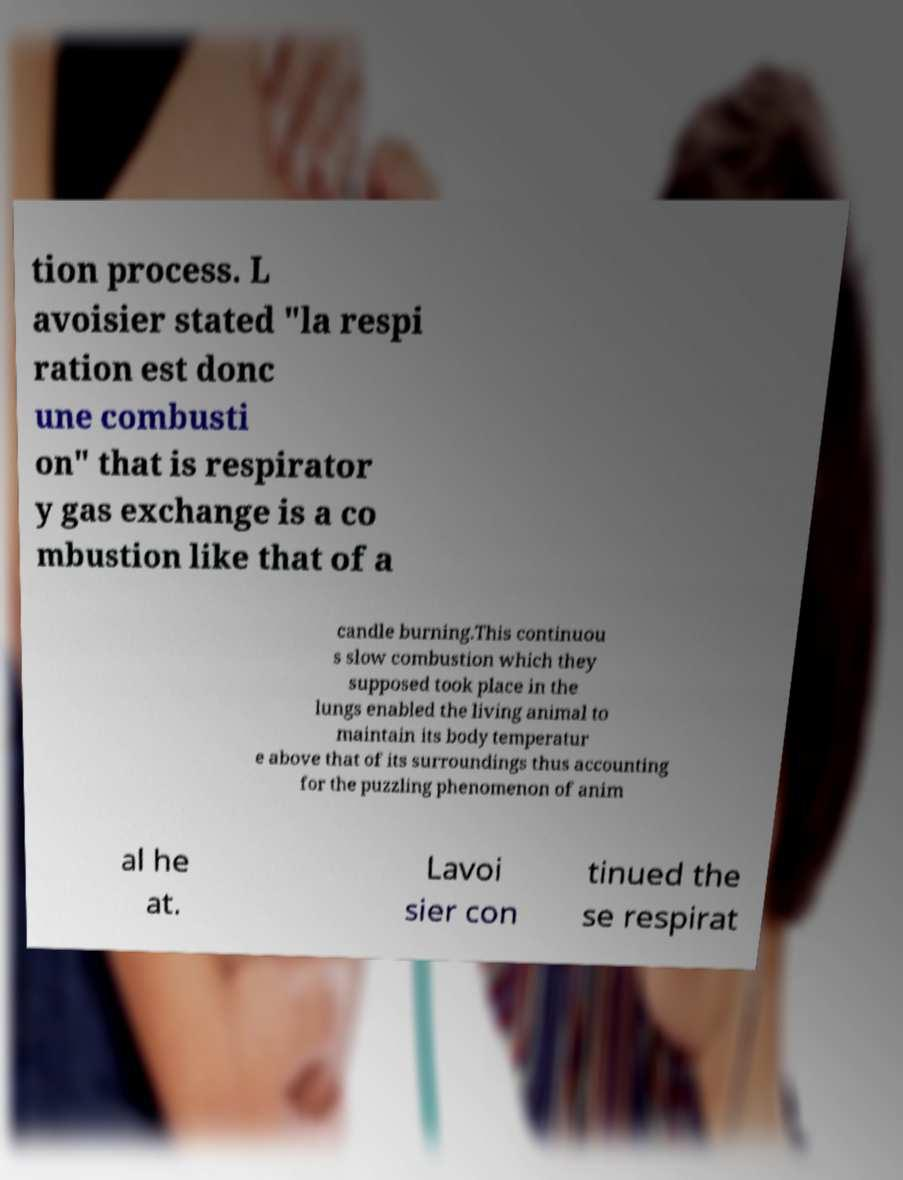Can you read and provide the text displayed in the image?This photo seems to have some interesting text. Can you extract and type it out for me? tion process. L avoisier stated "la respi ration est donc une combusti on" that is respirator y gas exchange is a co mbustion like that of a candle burning.This continuou s slow combustion which they supposed took place in the lungs enabled the living animal to maintain its body temperatur e above that of its surroundings thus accounting for the puzzling phenomenon of anim al he at. Lavoi sier con tinued the se respirat 